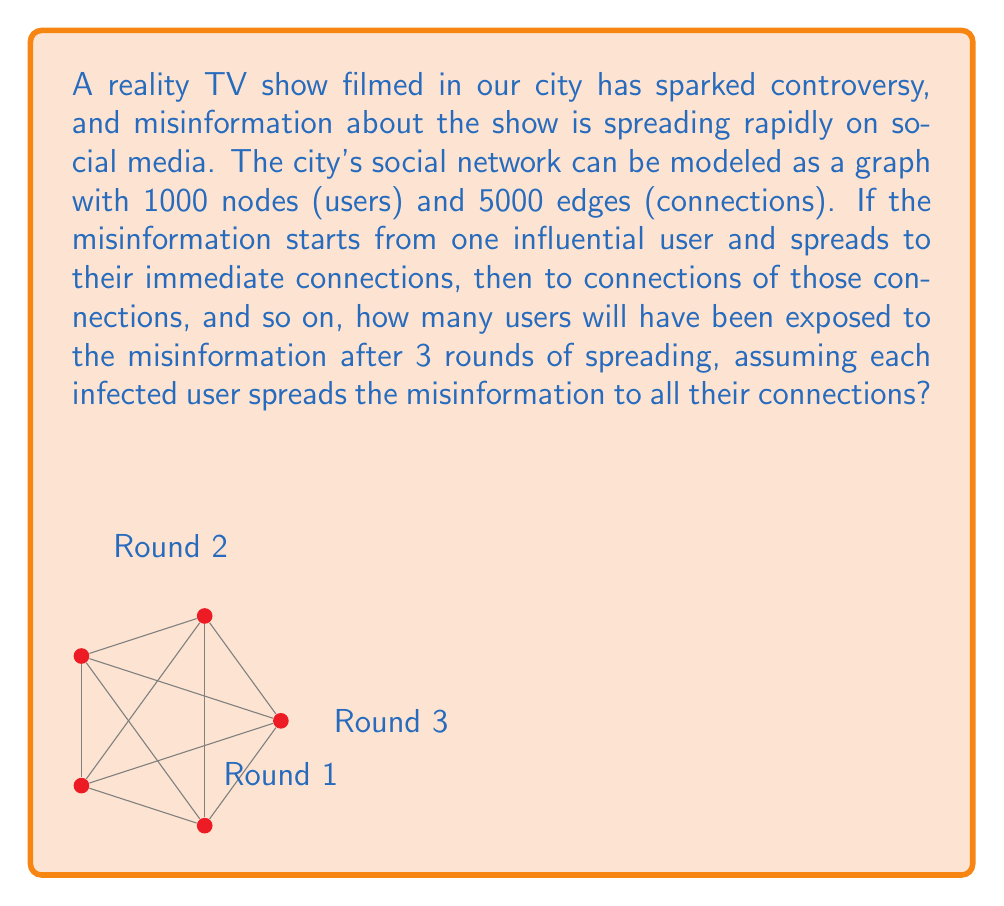Show me your answer to this math problem. Let's approach this step-by-step using a breadth-first search (BFS) algorithm:

1) First, we need to calculate the average degree of each node:
   $$ \text{Average Degree} = \frac{2 \times \text{Number of Edges}}{\text{Number of Nodes}} = \frac{2 \times 5000}{1000} = 10 $$

2) Now, let's calculate the number of users affected in each round:

   Round 1: The initial influential user
   $$ N_1 = 1 $$

   Round 2: The immediate connections of the initial user
   $$ N_2 = 10 $$ (average degree)

   Round 3: The connections of the users infected in Round 2
   $$ N_3 = 10 \times 9 = 90 $$ (each of the 10 users infects 9 new users on average)

3) The total number of users exposed after 3 rounds is the sum of these:
   $$ \text{Total} = N_1 + N_2 + N_3 = 1 + 10 + 90 = 101 $$

Note: We assume that the graph is large enough that we don't need to account for overlapping connections in these early rounds of spreading.
Answer: 101 users 